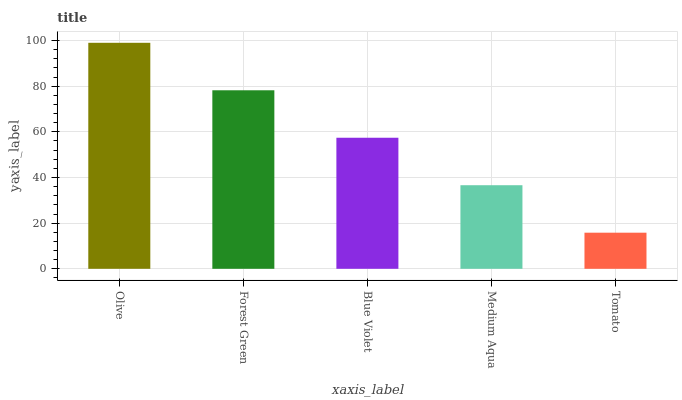Is Tomato the minimum?
Answer yes or no. Yes. Is Olive the maximum?
Answer yes or no. Yes. Is Forest Green the minimum?
Answer yes or no. No. Is Forest Green the maximum?
Answer yes or no. No. Is Olive greater than Forest Green?
Answer yes or no. Yes. Is Forest Green less than Olive?
Answer yes or no. Yes. Is Forest Green greater than Olive?
Answer yes or no. No. Is Olive less than Forest Green?
Answer yes or no. No. Is Blue Violet the high median?
Answer yes or no. Yes. Is Blue Violet the low median?
Answer yes or no. Yes. Is Medium Aqua the high median?
Answer yes or no. No. Is Medium Aqua the low median?
Answer yes or no. No. 